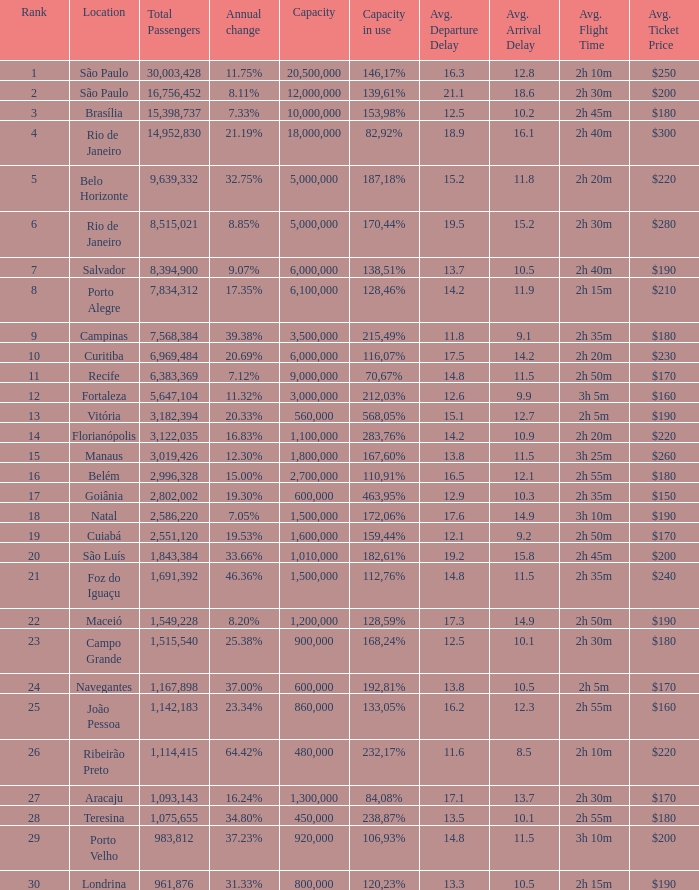What location has an in use capacity of 167,60%? 1800000.0. 